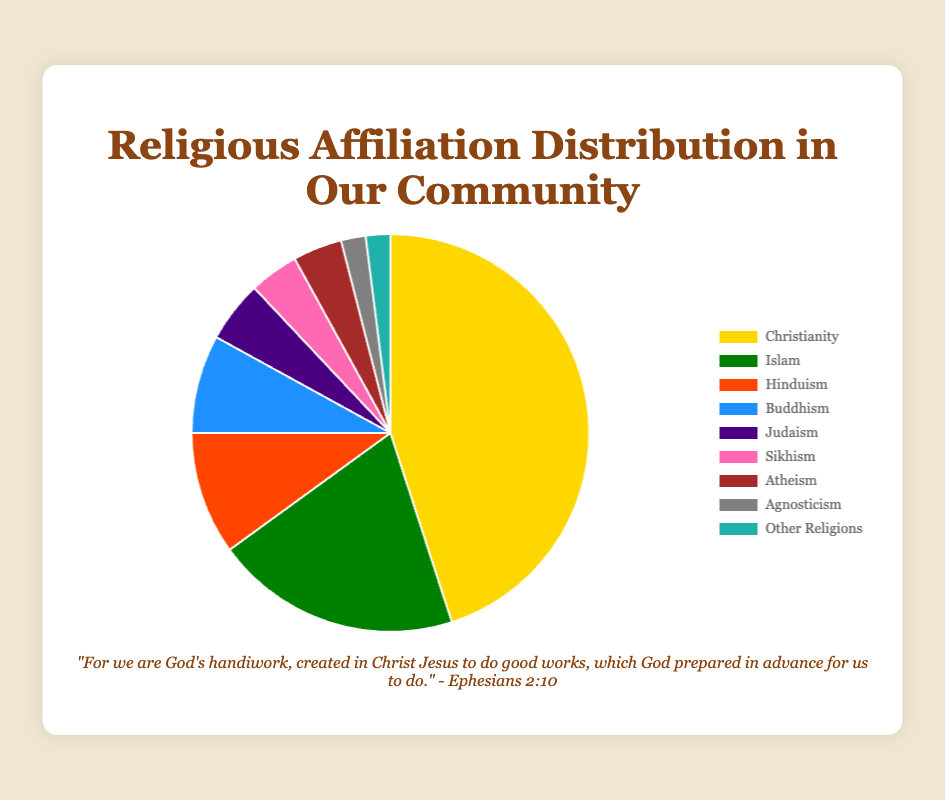What percentage of the community identifies as Hindus? To find the percentage, simply locate the section labeled "Hinduism" on the pie chart and read the corresponding percentage value.
Answer: 10% Which is larger, the percentage of Buddhists or Jews in the community? Compare the percentages for Buddhism and Judaism as shown on the pie chart. Buddhism is 8% and Judaism is 5%.
Answer: Buddhism How does the proportion of Christians compare to the combined percentage of Atheists and Agnostics? First, find the percentage for Christianity, Atheism, and Agnosticism from the pie chart. Christianity is 45%, Atheism is 4%, and Agnosticism is 2%. Then, sum the percentages for Atheism and Agnosticism (4% + 2% = 6%) and compare this to 45%.
Answer: Christianity is larger If Buddhist and Hindu percentages were combined, would they exceed the percentage of Islam? Add the percentage of Buddhists (8%) and Hindus (10%) and compare this sum (18%) with the percentage of Islam (20%).
Answer: No What is the combined percentage of minority religions (Judaism, Sikhism, and other religions)? Add the percentages of Judaism (5%), Sikhism (4%), and Other Religions (2%). The sum is 5% + 4% + 2% = 11%.
Answer: 11% Which religion has the third largest representation in the community? Rank the religions by their percentages (Christianity 45%, Islam 20%, Hinduism 10%, etc.). The third largest percentage is Hinduism (10%).
Answer: Hinduism How does the sum of the percentages for Christianity and Islam compare to the total percentage of all other affiliations combined? First, add the percentages for Christianity (45%) and Islam (20%) which is 65%. Then, add the percentages for all other affiliations (Hinduism 10%, Buddhism 8%, Judaism 5%, Sikhism 4%, Atheism 4%, Agnosticism 2%, Other Religions 2%) which sum to 35%. Compare 65% to 35%.
Answer: Christianity and Islam together have a higher percentage 